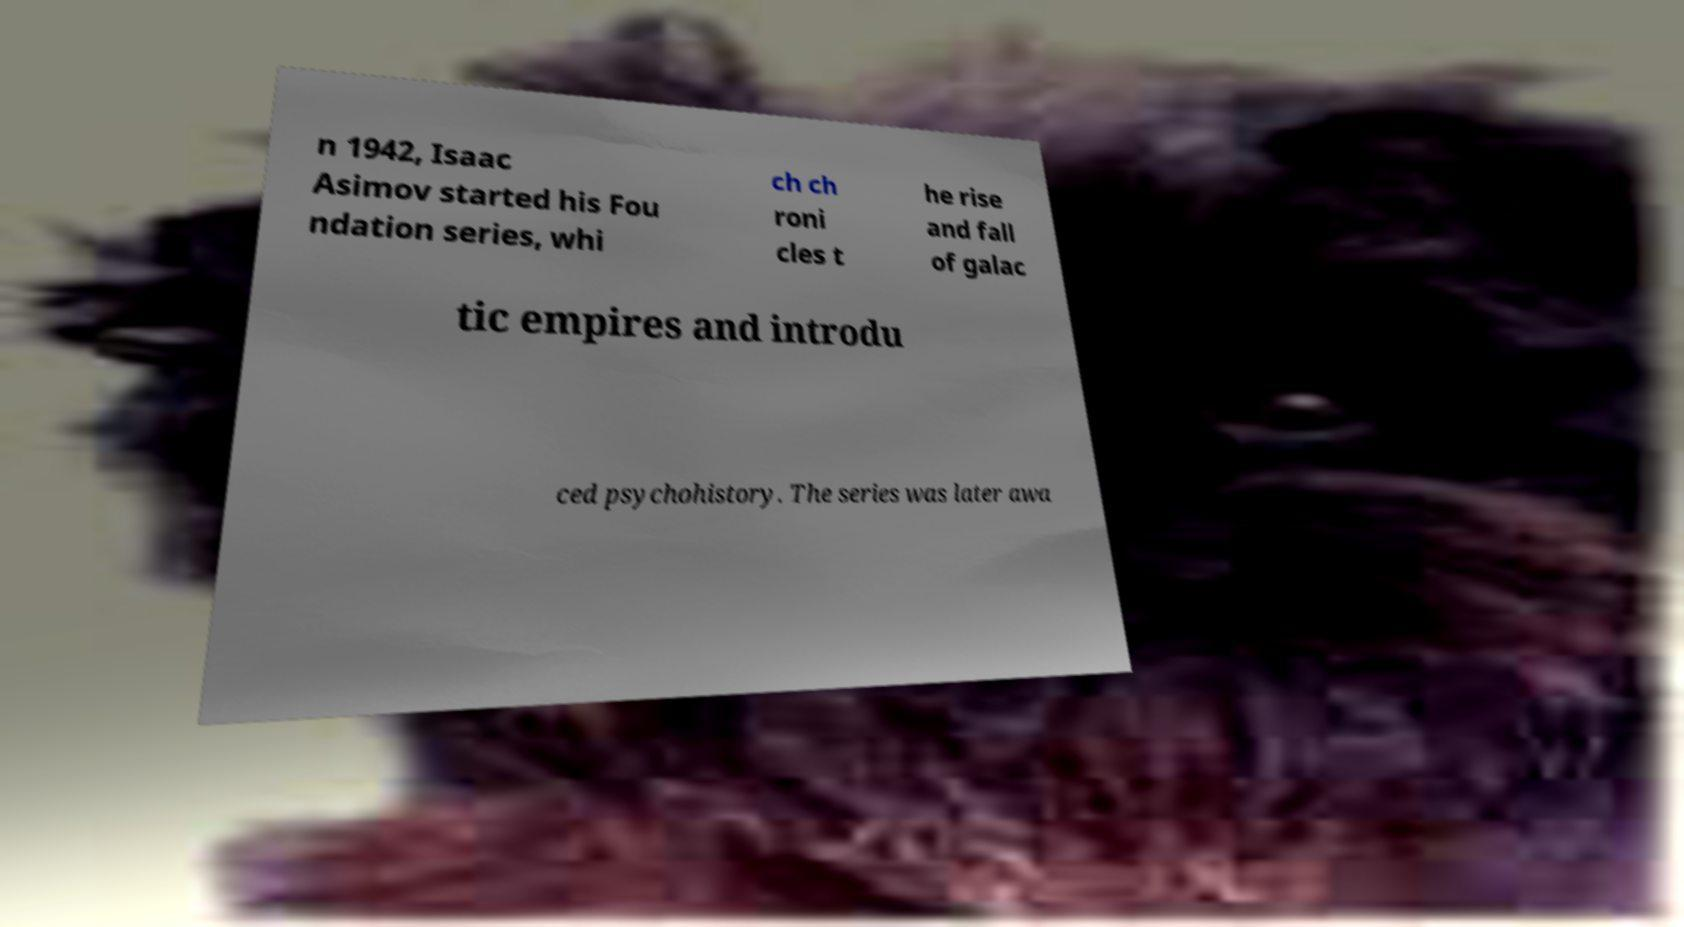I need the written content from this picture converted into text. Can you do that? n 1942, Isaac Asimov started his Fou ndation series, whi ch ch roni cles t he rise and fall of galac tic empires and introdu ced psychohistory. The series was later awa 